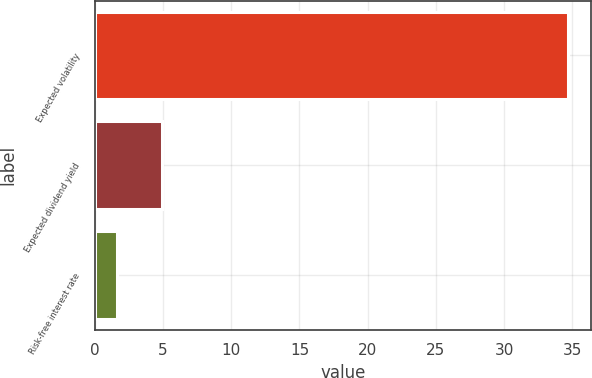Convert chart to OTSL. <chart><loc_0><loc_0><loc_500><loc_500><bar_chart><fcel>Expected volatility<fcel>Expected dividend yield<fcel>Risk-free interest rate<nl><fcel>34.67<fcel>4.92<fcel>1.61<nl></chart> 